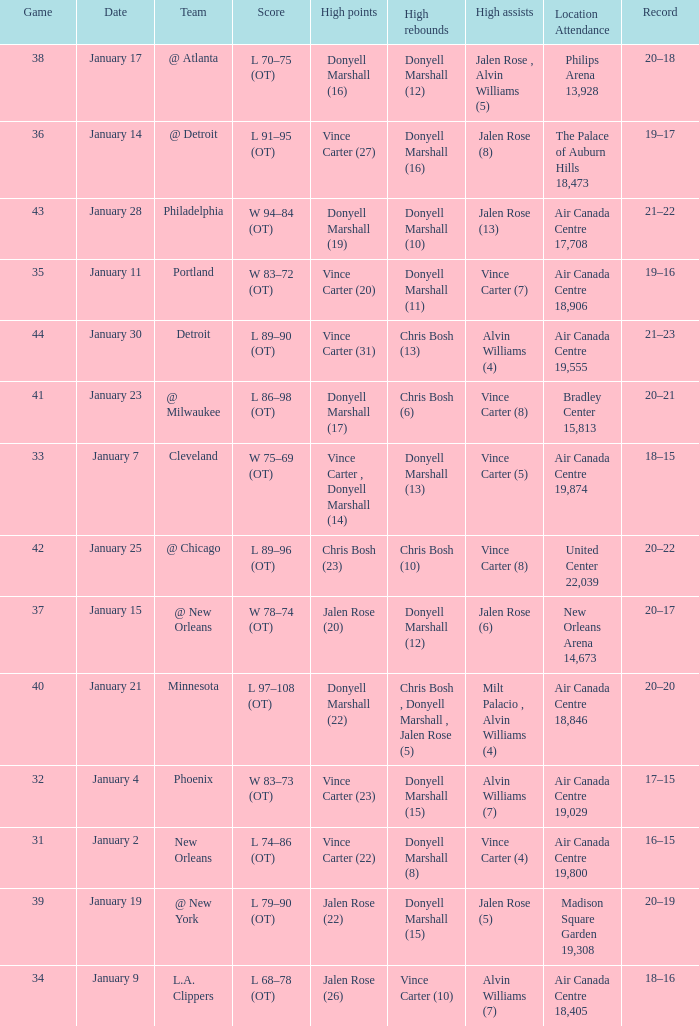What is the Location and Attendance with a Record of 21–22? Air Canada Centre 17,708. 